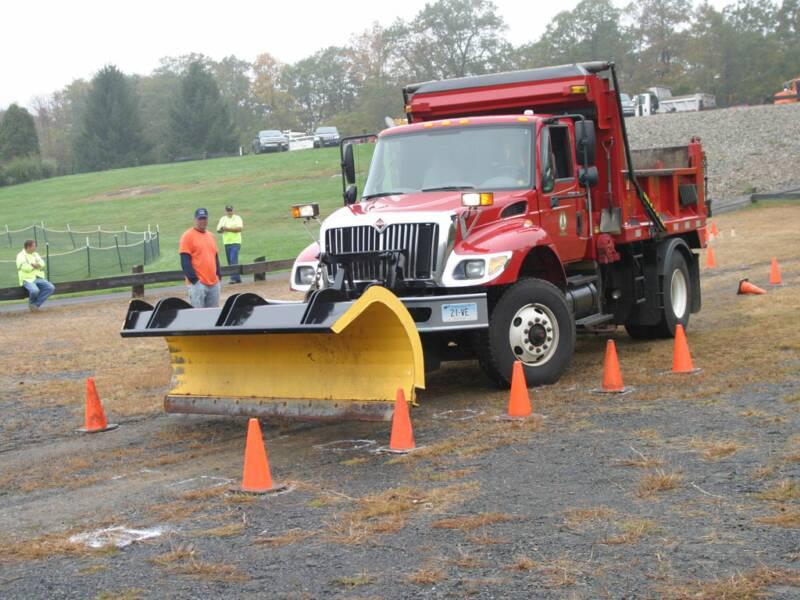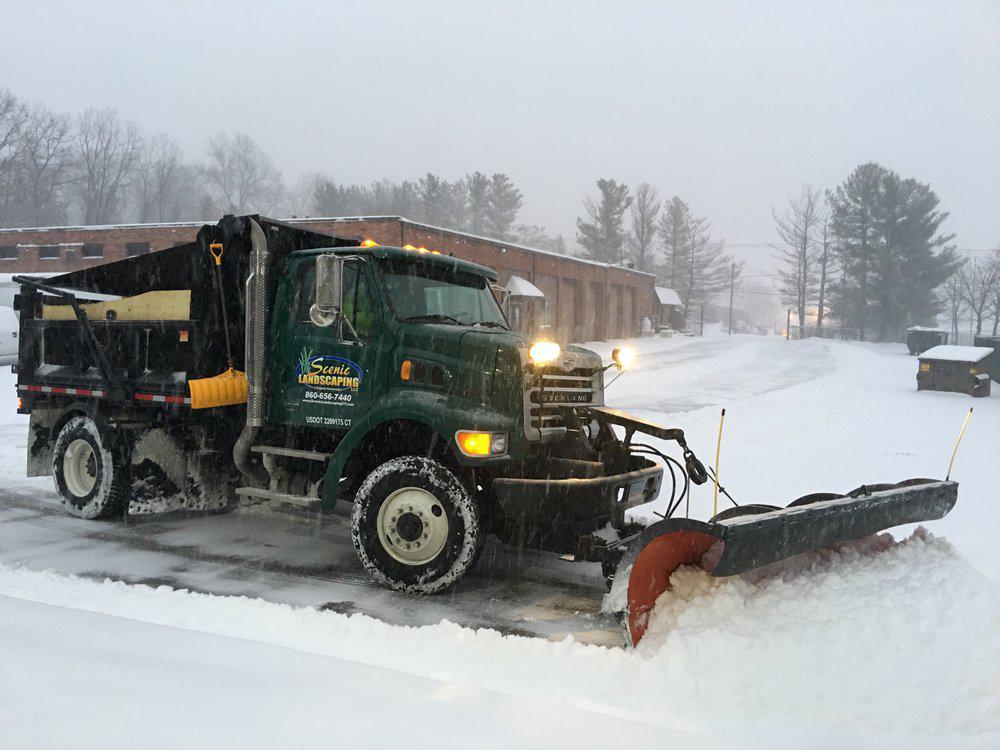The first image is the image on the left, the second image is the image on the right. For the images displayed, is the sentence "A truck in each image is equipped with a front-facing orange show blade, but neither truck is plowing snow." factually correct? Answer yes or no. No. The first image is the image on the left, the second image is the image on the right. Analyze the images presented: Is the assertion "Only one of the images features a red truck, with a plow attachment." valid? Answer yes or no. Yes. 